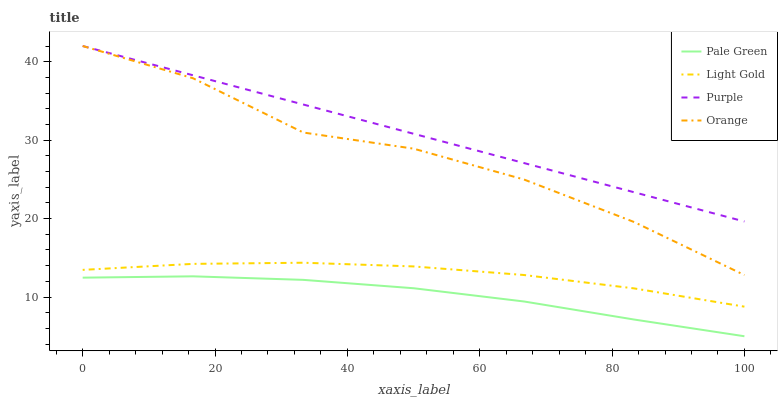Does Pale Green have the minimum area under the curve?
Answer yes or no. Yes. Does Purple have the maximum area under the curve?
Answer yes or no. Yes. Does Orange have the minimum area under the curve?
Answer yes or no. No. Does Orange have the maximum area under the curve?
Answer yes or no. No. Is Purple the smoothest?
Answer yes or no. Yes. Is Orange the roughest?
Answer yes or no. Yes. Is Pale Green the smoothest?
Answer yes or no. No. Is Pale Green the roughest?
Answer yes or no. No. Does Pale Green have the lowest value?
Answer yes or no. Yes. Does Orange have the lowest value?
Answer yes or no. No. Does Orange have the highest value?
Answer yes or no. Yes. Does Pale Green have the highest value?
Answer yes or no. No. Is Pale Green less than Light Gold?
Answer yes or no. Yes. Is Purple greater than Pale Green?
Answer yes or no. Yes. Does Purple intersect Orange?
Answer yes or no. Yes. Is Purple less than Orange?
Answer yes or no. No. Is Purple greater than Orange?
Answer yes or no. No. Does Pale Green intersect Light Gold?
Answer yes or no. No. 